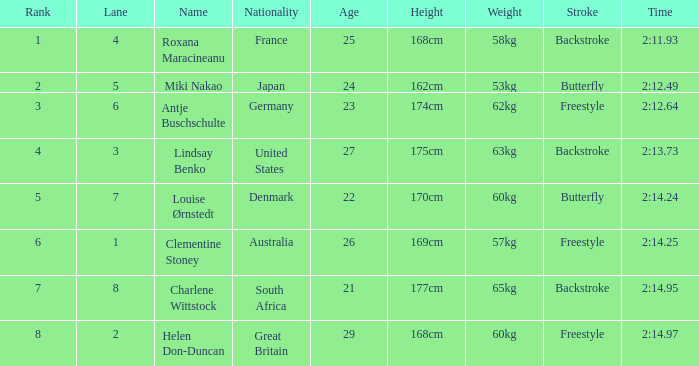Give me the full table as a dictionary. {'header': ['Rank', 'Lane', 'Name', 'Nationality', 'Age', 'Height', 'Weight', 'Stroke', 'Time'], 'rows': [['1', '4', 'Roxana Maracineanu', 'France', '25', '168cm', '58kg', 'Backstroke', '2:11.93'], ['2', '5', 'Miki Nakao', 'Japan', '24', '162cm', '53kg', 'Butterfly', '2:12.49'], ['3', '6', 'Antje Buschschulte', 'Germany', '23', '174cm', '62kg', 'Freestyle', '2:12.64'], ['4', '3', 'Lindsay Benko', 'United States', '27', '175cm', '63kg', 'Backstroke', '2:13.73'], ['5', '7', 'Louise Ørnstedt', 'Denmark', '22', '170cm', '60kg', 'Butterfly', '2:14.24'], ['6', '1', 'Clementine Stoney', 'Australia', '26', '169cm', '57kg', 'Freestyle', '2:14.25'], ['7', '8', 'Charlene Wittstock', 'South Africa', '21', '177cm', '65kg', 'Backstroke', '2:14.95'], ['8', '2', 'Helen Don-Duncan', 'Great Britain', '29', '168cm', '60kg', 'Freestyle', '2:14.97']]} What is the number of lane with a rank more than 2 for louise ørnstedt? 1.0. 